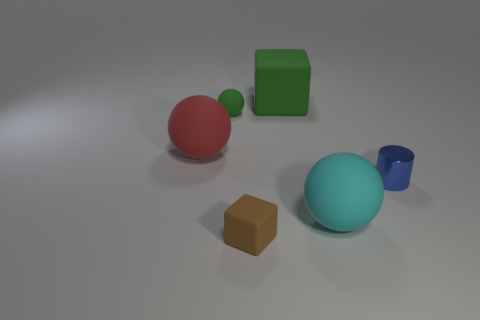Add 2 big cyan rubber things. How many objects exist? 8 Subtract all cubes. How many objects are left? 4 Add 4 cyan objects. How many cyan objects are left? 5 Add 4 blue cubes. How many blue cubes exist? 4 Subtract 0 gray balls. How many objects are left? 6 Subtract all big red rubber spheres. Subtract all tiny green spheres. How many objects are left? 4 